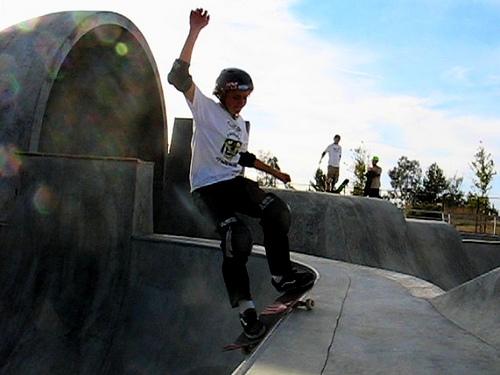Is there more than one person skateboarding?
Short answer required. Yes. Is this boy wearing shoes?
Answer briefly. Yes. Is this child wearing sufficient protective gear for this sport?
Be succinct. Yes. 